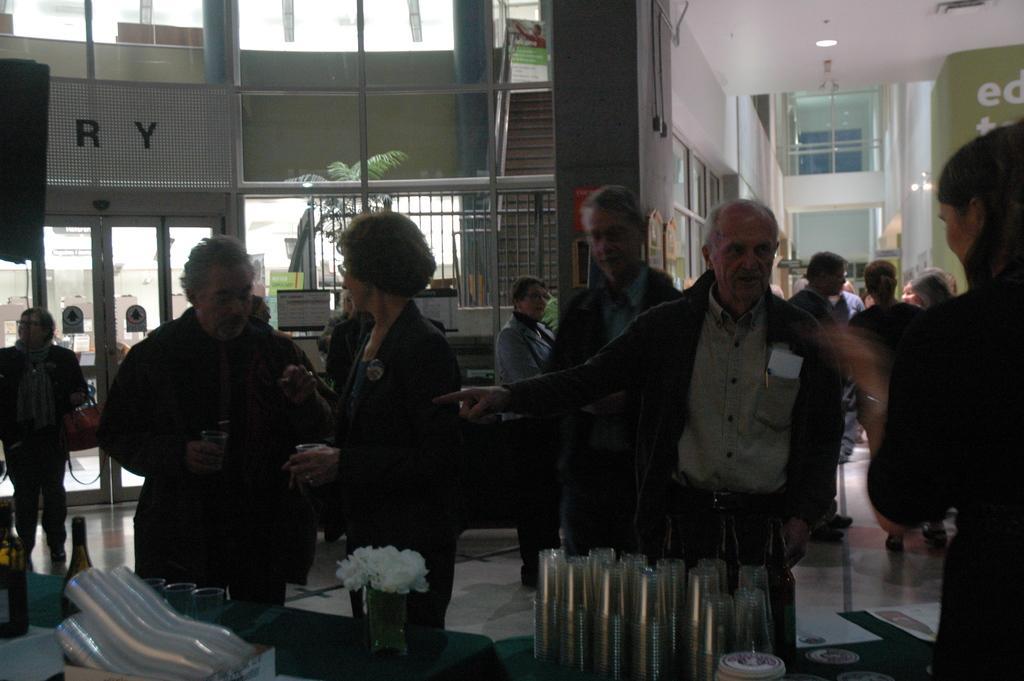In one or two sentences, can you explain what this image depicts? In this image we can see glasses, bottles and flower vase are placed on the table and these people are standing on the floor. In the background, we can see the wall, stairs, glass doors, plant and the ceiling lights. 